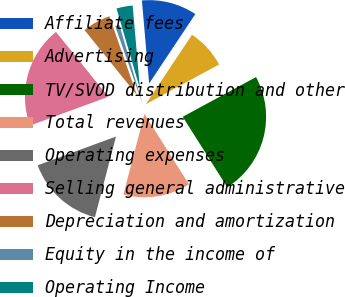Convert chart to OTSL. <chart><loc_0><loc_0><loc_500><loc_500><pie_chart><fcel>Affiliate fees<fcel>Advertising<fcel>TV/SVOD distribution and other<fcel>Total revenues<fcel>Operating expenses<fcel>Selling general administrative<fcel>Depreciation and amortization<fcel>Equity in the income of<fcel>Operating Income<nl><fcel>10.73%<fcel>7.76%<fcel>23.93%<fcel>13.04%<fcel>15.35%<fcel>19.8%<fcel>5.45%<fcel>0.83%<fcel>3.14%<nl></chart> 